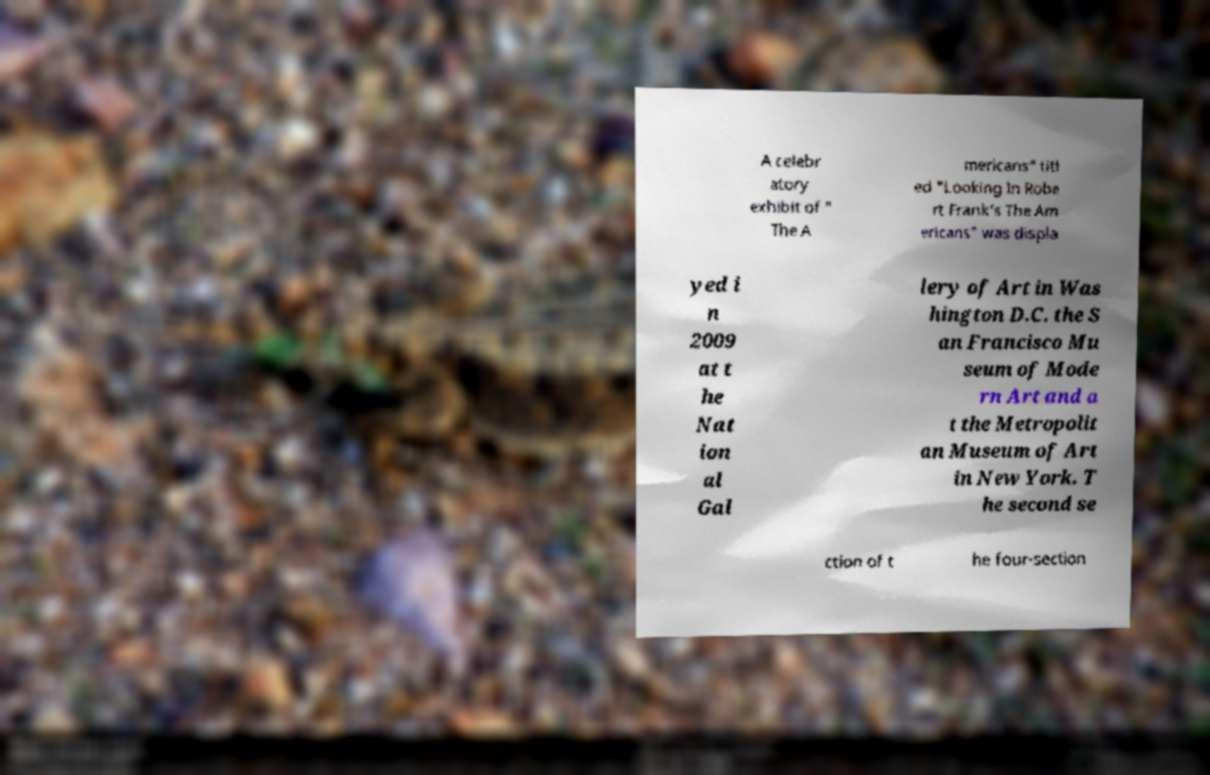Could you assist in decoding the text presented in this image and type it out clearly? A celebr atory exhibit of " The A mericans" titl ed "Looking In Robe rt Frank's The Am ericans" was displa yed i n 2009 at t he Nat ion al Gal lery of Art in Was hington D.C. the S an Francisco Mu seum of Mode rn Art and a t the Metropolit an Museum of Art in New York. T he second se ction of t he four-section 